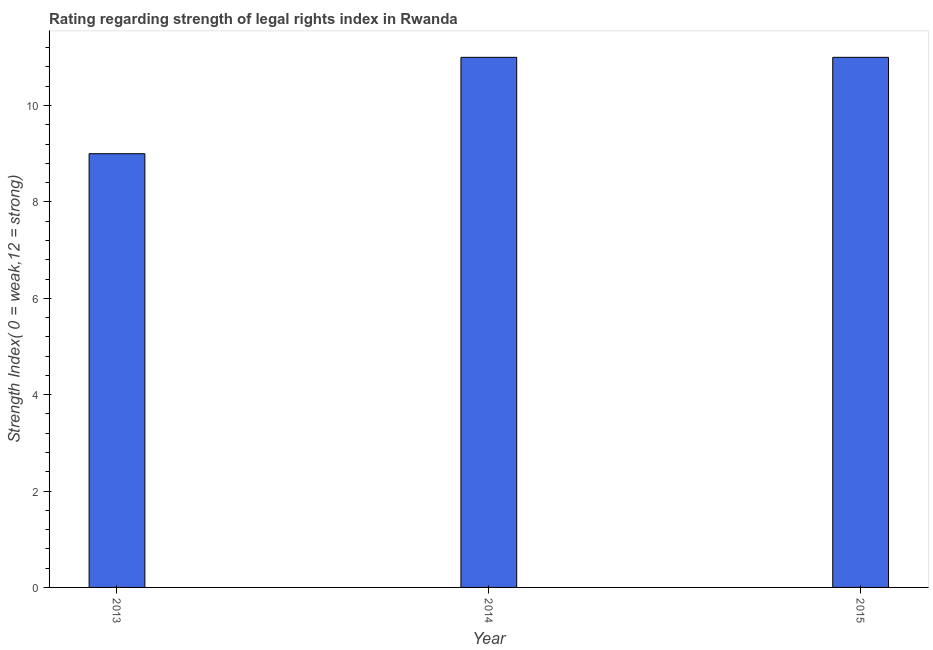Does the graph contain any zero values?
Your answer should be compact. No. What is the title of the graph?
Keep it short and to the point. Rating regarding strength of legal rights index in Rwanda. What is the label or title of the X-axis?
Your answer should be very brief. Year. What is the label or title of the Y-axis?
Provide a succinct answer. Strength Index( 0 = weak,12 = strong). What is the sum of the strength of legal rights index?
Make the answer very short. 31. What is the difference between the strength of legal rights index in 2013 and 2015?
Your answer should be very brief. -2. What is the median strength of legal rights index?
Offer a very short reply. 11. In how many years, is the strength of legal rights index greater than 2 ?
Offer a terse response. 3. What is the ratio of the strength of legal rights index in 2013 to that in 2014?
Ensure brevity in your answer.  0.82. Is the strength of legal rights index in 2014 less than that in 2015?
Make the answer very short. No. Is the sum of the strength of legal rights index in 2014 and 2015 greater than the maximum strength of legal rights index across all years?
Your answer should be compact. Yes. In how many years, is the strength of legal rights index greater than the average strength of legal rights index taken over all years?
Make the answer very short. 2. Are all the bars in the graph horizontal?
Offer a very short reply. No. What is the difference between two consecutive major ticks on the Y-axis?
Give a very brief answer. 2. Are the values on the major ticks of Y-axis written in scientific E-notation?
Keep it short and to the point. No. What is the Strength Index( 0 = weak,12 = strong) of 2013?
Keep it short and to the point. 9. What is the Strength Index( 0 = weak,12 = strong) in 2014?
Offer a very short reply. 11. What is the difference between the Strength Index( 0 = weak,12 = strong) in 2013 and 2014?
Offer a terse response. -2. What is the difference between the Strength Index( 0 = weak,12 = strong) in 2013 and 2015?
Make the answer very short. -2. What is the difference between the Strength Index( 0 = weak,12 = strong) in 2014 and 2015?
Give a very brief answer. 0. What is the ratio of the Strength Index( 0 = weak,12 = strong) in 2013 to that in 2014?
Provide a succinct answer. 0.82. What is the ratio of the Strength Index( 0 = weak,12 = strong) in 2013 to that in 2015?
Offer a very short reply. 0.82. 